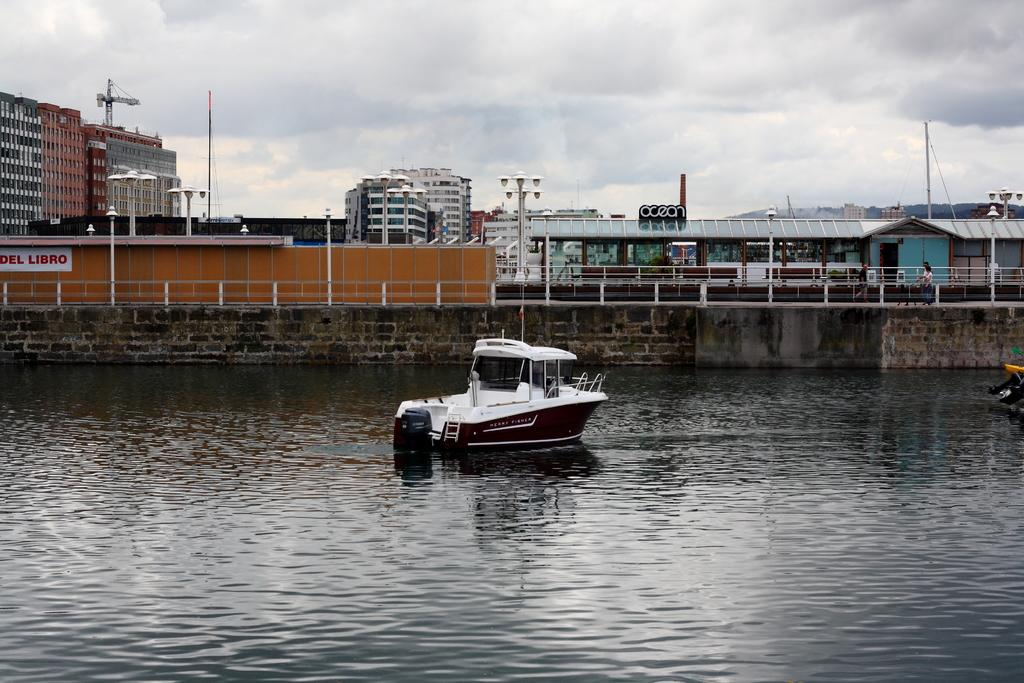<image>
Present a compact description of the photo's key features. A boat is on a body of water with a wall, a fence and a sign nearby that says DEL LIBRO. 